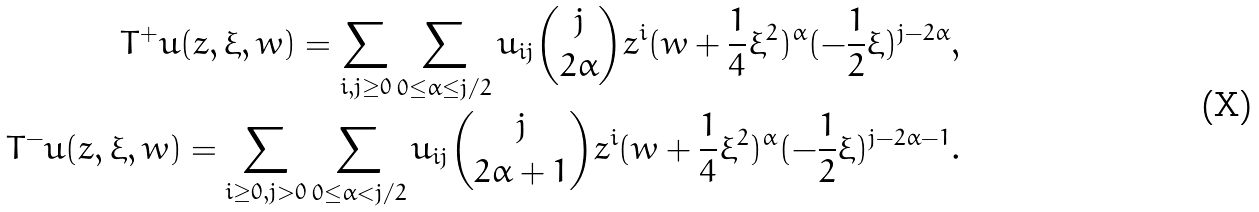Convert formula to latex. <formula><loc_0><loc_0><loc_500><loc_500>T ^ { + } u ( z , \xi , w ) = \sum _ { i , j \geq 0 } \sum _ { 0 \leq \alpha \leq j / 2 } u _ { i j } \binom { j } { 2 \alpha } z ^ { i } ( w + \frac { 1 } { 4 } \xi ^ { 2 } ) ^ { \alpha } ( - \frac { 1 } { 2 } \xi ) ^ { j - 2 \alpha } , \\ T ^ { - } u ( z , \xi , w ) = \sum _ { i \geq 0 , j > 0 } \sum _ { 0 \leq \alpha < j / 2 } u _ { i j } \binom { j } { 2 \alpha + 1 } z ^ { i } ( w + \frac { 1 } { 4 } \xi ^ { 2 } ) ^ { \alpha } ( - \frac { 1 } { 2 } \xi ) ^ { j - 2 \alpha - 1 } .</formula> 